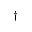Convert formula to latex. <formula><loc_0><loc_0><loc_500><loc_500>\dagger</formula> 